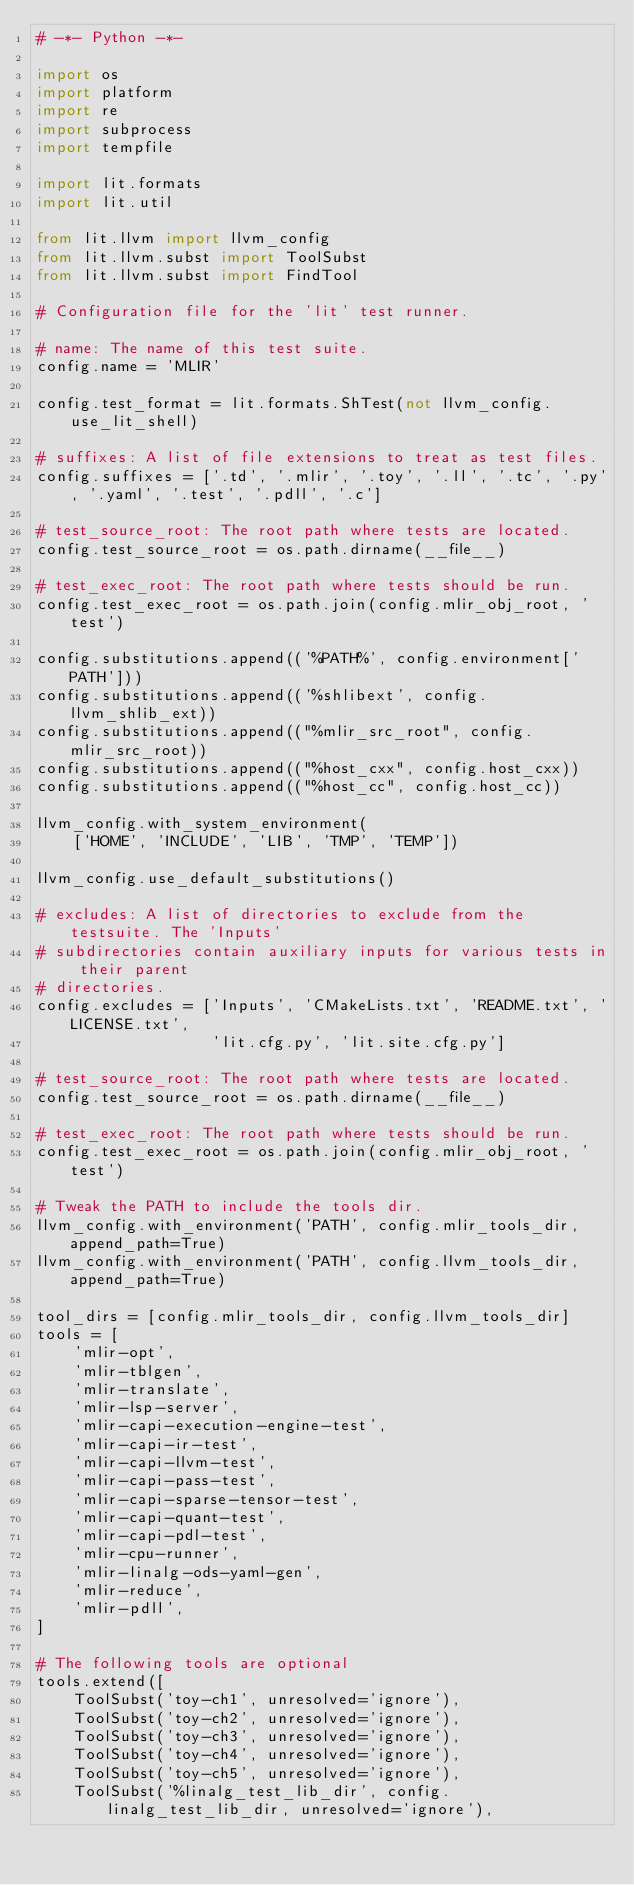Convert code to text. <code><loc_0><loc_0><loc_500><loc_500><_Python_># -*- Python -*-

import os
import platform
import re
import subprocess
import tempfile

import lit.formats
import lit.util

from lit.llvm import llvm_config
from lit.llvm.subst import ToolSubst
from lit.llvm.subst import FindTool

# Configuration file for the 'lit' test runner.

# name: The name of this test suite.
config.name = 'MLIR'

config.test_format = lit.formats.ShTest(not llvm_config.use_lit_shell)

# suffixes: A list of file extensions to treat as test files.
config.suffixes = ['.td', '.mlir', '.toy', '.ll', '.tc', '.py', '.yaml', '.test', '.pdll', '.c']

# test_source_root: The root path where tests are located.
config.test_source_root = os.path.dirname(__file__)

# test_exec_root: The root path where tests should be run.
config.test_exec_root = os.path.join(config.mlir_obj_root, 'test')

config.substitutions.append(('%PATH%', config.environment['PATH']))
config.substitutions.append(('%shlibext', config.llvm_shlib_ext))
config.substitutions.append(("%mlir_src_root", config.mlir_src_root))
config.substitutions.append(("%host_cxx", config.host_cxx))
config.substitutions.append(("%host_cc", config.host_cc))

llvm_config.with_system_environment(
    ['HOME', 'INCLUDE', 'LIB', 'TMP', 'TEMP'])

llvm_config.use_default_substitutions()

# excludes: A list of directories to exclude from the testsuite. The 'Inputs'
# subdirectories contain auxiliary inputs for various tests in their parent
# directories.
config.excludes = ['Inputs', 'CMakeLists.txt', 'README.txt', 'LICENSE.txt',
                   'lit.cfg.py', 'lit.site.cfg.py']

# test_source_root: The root path where tests are located.
config.test_source_root = os.path.dirname(__file__)

# test_exec_root: The root path where tests should be run.
config.test_exec_root = os.path.join(config.mlir_obj_root, 'test')

# Tweak the PATH to include the tools dir.
llvm_config.with_environment('PATH', config.mlir_tools_dir, append_path=True)
llvm_config.with_environment('PATH', config.llvm_tools_dir, append_path=True)

tool_dirs = [config.mlir_tools_dir, config.llvm_tools_dir]
tools = [
    'mlir-opt',
    'mlir-tblgen',
    'mlir-translate',
    'mlir-lsp-server',
    'mlir-capi-execution-engine-test',
    'mlir-capi-ir-test',
    'mlir-capi-llvm-test',
    'mlir-capi-pass-test',
    'mlir-capi-sparse-tensor-test',
    'mlir-capi-quant-test',
    'mlir-capi-pdl-test',
    'mlir-cpu-runner',
    'mlir-linalg-ods-yaml-gen',
    'mlir-reduce',
    'mlir-pdll',
]

# The following tools are optional
tools.extend([
    ToolSubst('toy-ch1', unresolved='ignore'),
    ToolSubst('toy-ch2', unresolved='ignore'),
    ToolSubst('toy-ch3', unresolved='ignore'),
    ToolSubst('toy-ch4', unresolved='ignore'),
    ToolSubst('toy-ch5', unresolved='ignore'),
    ToolSubst('%linalg_test_lib_dir', config.linalg_test_lib_dir, unresolved='ignore'),</code> 